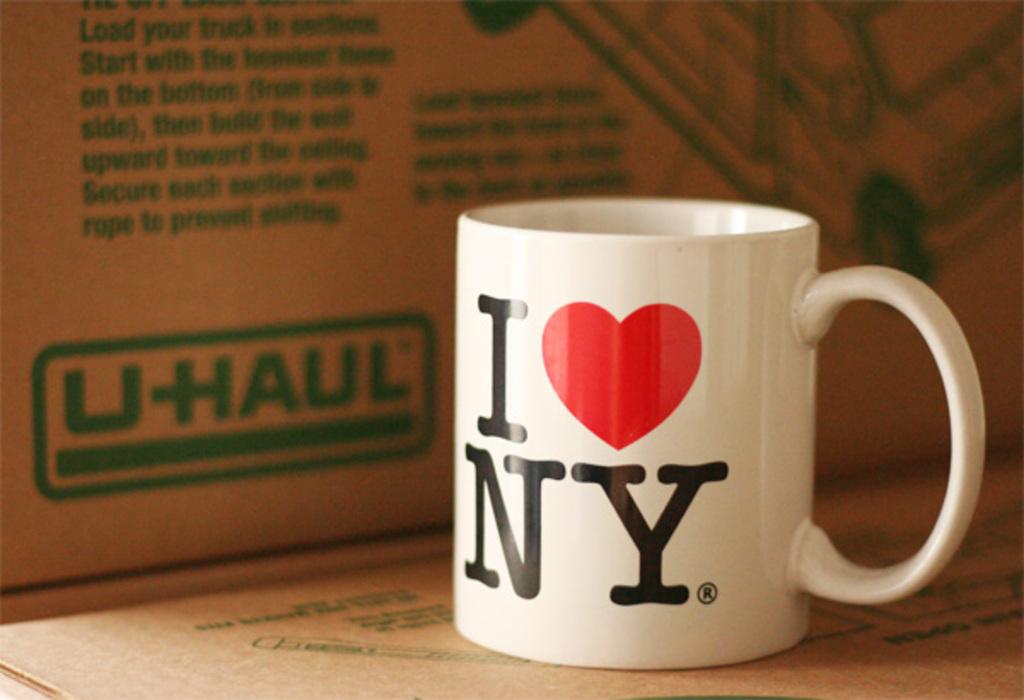What city does this person love?
Your response must be concise. New york. 